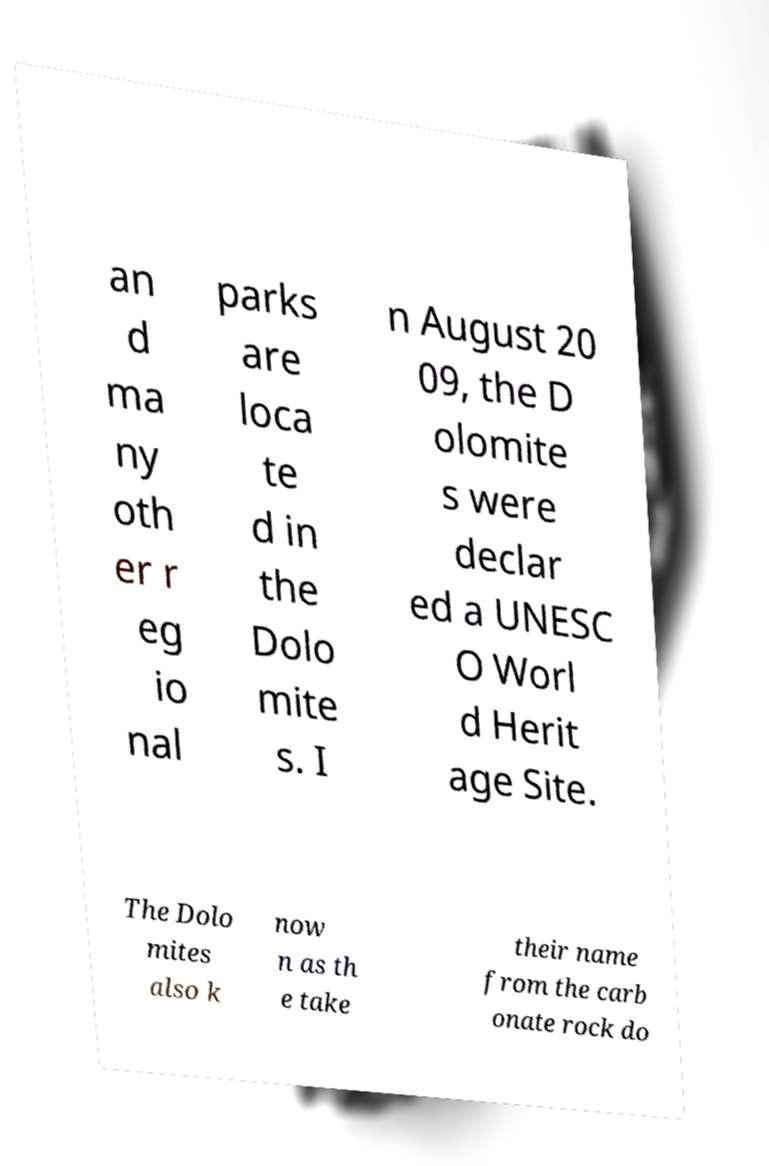There's text embedded in this image that I need extracted. Can you transcribe it verbatim? an d ma ny oth er r eg io nal parks are loca te d in the Dolo mite s. I n August 20 09, the D olomite s were declar ed a UNESC O Worl d Herit age Site. The Dolo mites also k now n as th e take their name from the carb onate rock do 